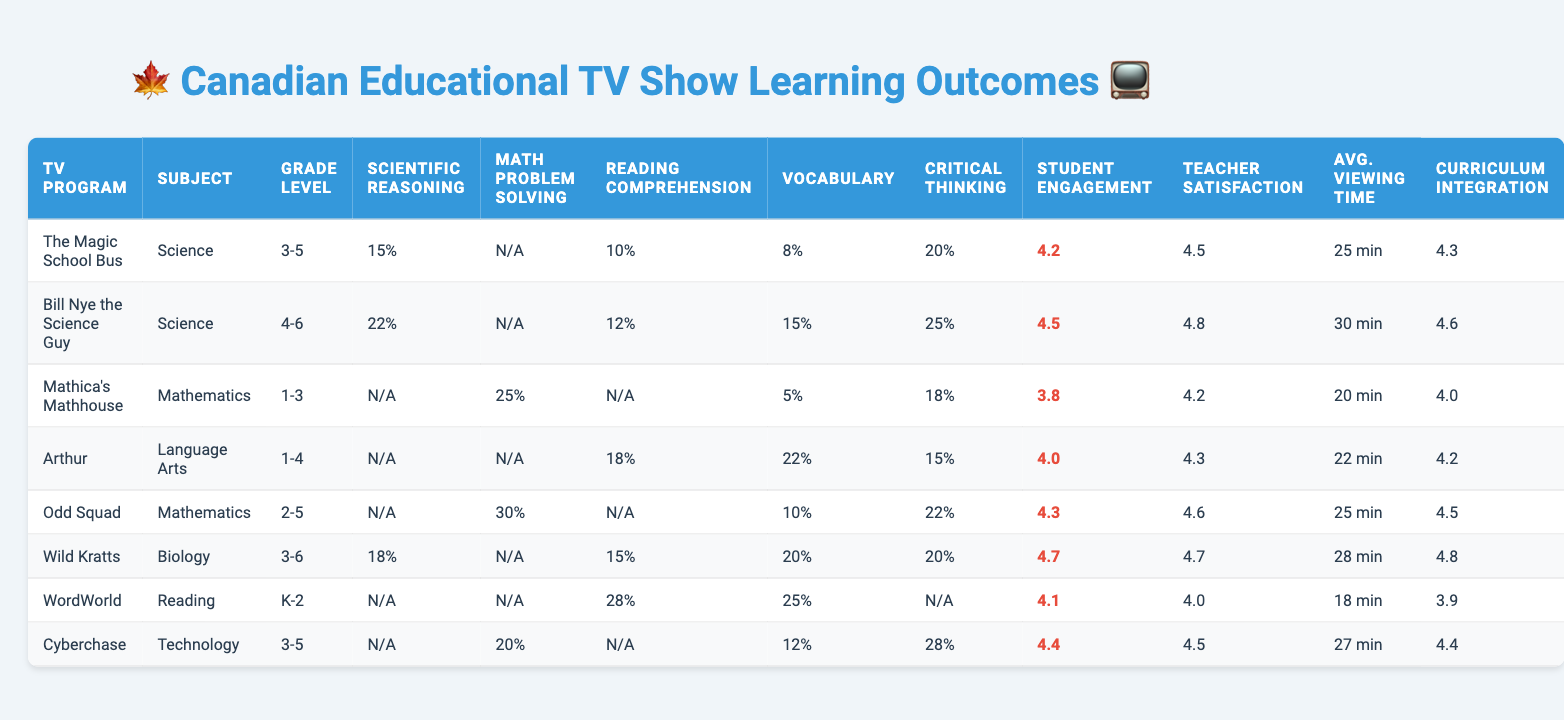What is the student engagement score for "Wild Kratts"? The table shows the student engagement score for "Wild Kratts" as 4.7.
Answer: 4.7 Which TV program has the highest teacher satisfaction rating? By comparing the teacher satisfaction ratings, "Bill Nye the Science Guy" has the highest rating at 4.8.
Answer: Bill Nye the Science Guy What is the average improvement in vocabulary across all TV programs? The improvements in vocabulary are 8, 15, 5, 22, 10, 20, 25, and 12. Summing these gives 117, which divided by 8 (the number of programs) equals 14.625.
Answer: 14.625 Is there any improvement in reading comprehension for "Mathica's Mathhouse"? The table indicates that there is no reported improvement in reading comprehension for "Mathica's Mathhouse" as the value is marked as null.
Answer: No How do the student engagement scores of "The Magic School Bus" and "Cyberchase" compare? "The Magic School Bus" has a student engagement score of 4.2, while "Cyberchase" has a score of 4.4, indicating that "Cyberchase" is slightly higher.
Answer: Cyberchase is higher What TV program shows no improvement in scientific reasoning? The table lists "Mathica's Mathhouse", "Arthur", "Odd Squad", "WordWorld", and "Cyberchase" showing no improvement in scientific reasoning as their values are null.
Answer: Multiple programs have no improvement Which subjects have programs that scored above 20% in critical thinking improvement? The improvement in critical thinking above 20% can be found in "Bill Nye the Science Guy" (25%), "Odd Squad" (22%), and "Cyberchase" (28%).
Answer: Three programs What is the total improvement in math problem solving for all listed programs? The improvements listed are 25, 30, and 20. Adding these gives a total of 75.
Answer: 75 Which program has the lowest average viewing time and what is it? By looking at the average viewing times, "WordWorld" has the lowest time at 18 minutes.
Answer: WordWorld, 18 minutes Is the improvement in vocabulary higher for "Arthur" or for "Wild Kratts"? "Arthur" shows a vocabulary improvement of 22%, while "Wild Kratts" shows 20%. Therefore, "Arthur" is higher.
Answer: Arthur is higher If we consider only the improvement in vocabulary, which program has the maximum and what is the value? "WordWorld" has the maximum improvement in vocabulary at 25%.
Answer: WordWorld, 25% 